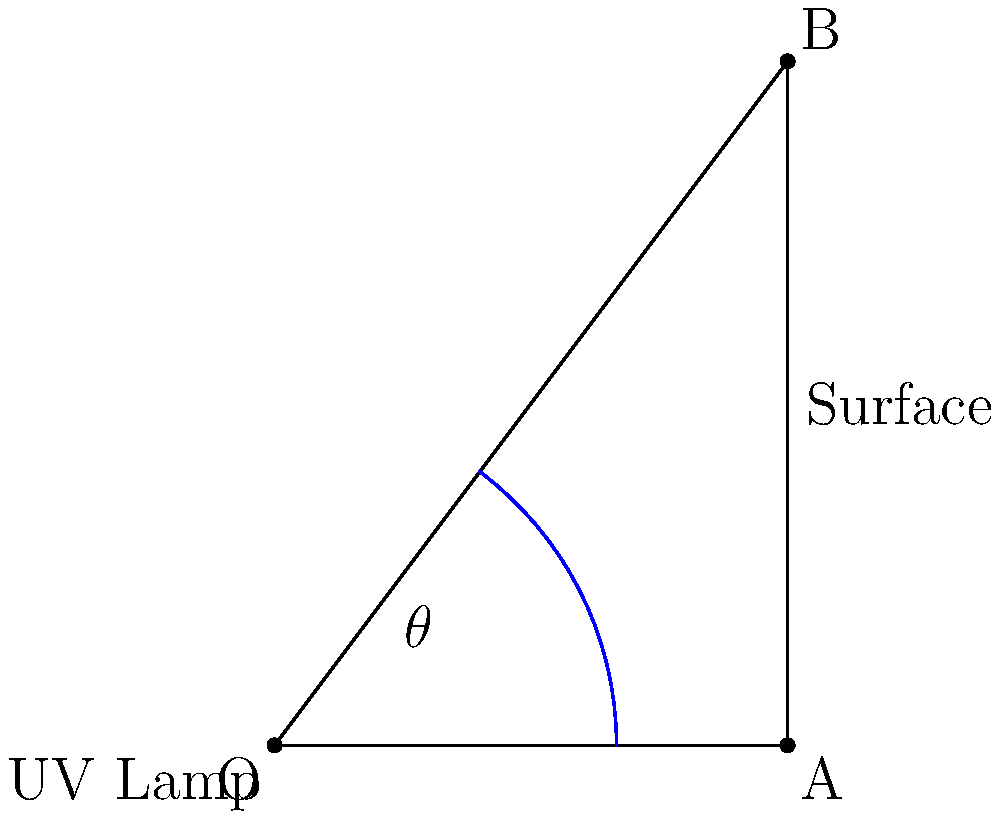A UV lamp is used for surface disinfection. If the lamp is placed at point O and needs to cover a surface from point A to point B, what angle $\theta$ (in degrees) should the UV light beam make to ensure effective disinfection of the entire surface? To find the angle $\theta$, we need to use trigonometry:

1) First, identify the right triangle OAB.
2) We need to find the angle at O, which is our $\theta$.
3) We can use the arctangent function to find this angle.
4) The opposite side is AB, which is 4 units long.
5) The adjacent side is OA, which is 3 units long.
6) The formula for $\theta$ is:

   $\theta = \arctan(\frac{\text{opposite}}{\text{adjacent}})$

7) Plugging in our values:

   $\theta = \arctan(\frac{4}{3})$

8) Using a calculator or trigonometric tables:

   $\theta \approx 53.13^\circ$

Therefore, the UV light beam should make an angle of approximately 53.13° to cover the entire surface effectively.
Answer: $53.13^\circ$ 